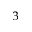Convert formula to latex. <formula><loc_0><loc_0><loc_500><loc_500>^ { 3 }</formula> 